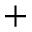Convert formula to latex. <formula><loc_0><loc_0><loc_500><loc_500>+</formula> 